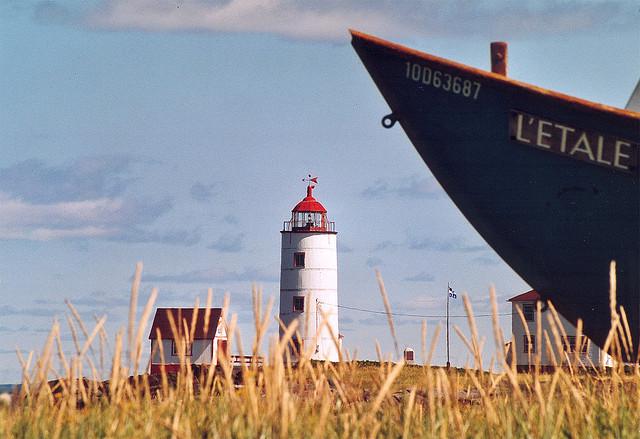What is the name of the building with the red tower?
Keep it brief. Lighthouse. What's the registration number of the boat?
Answer briefly. 10063687. Why would there be a boat on land?
Answer briefly. People going out to sea later. 